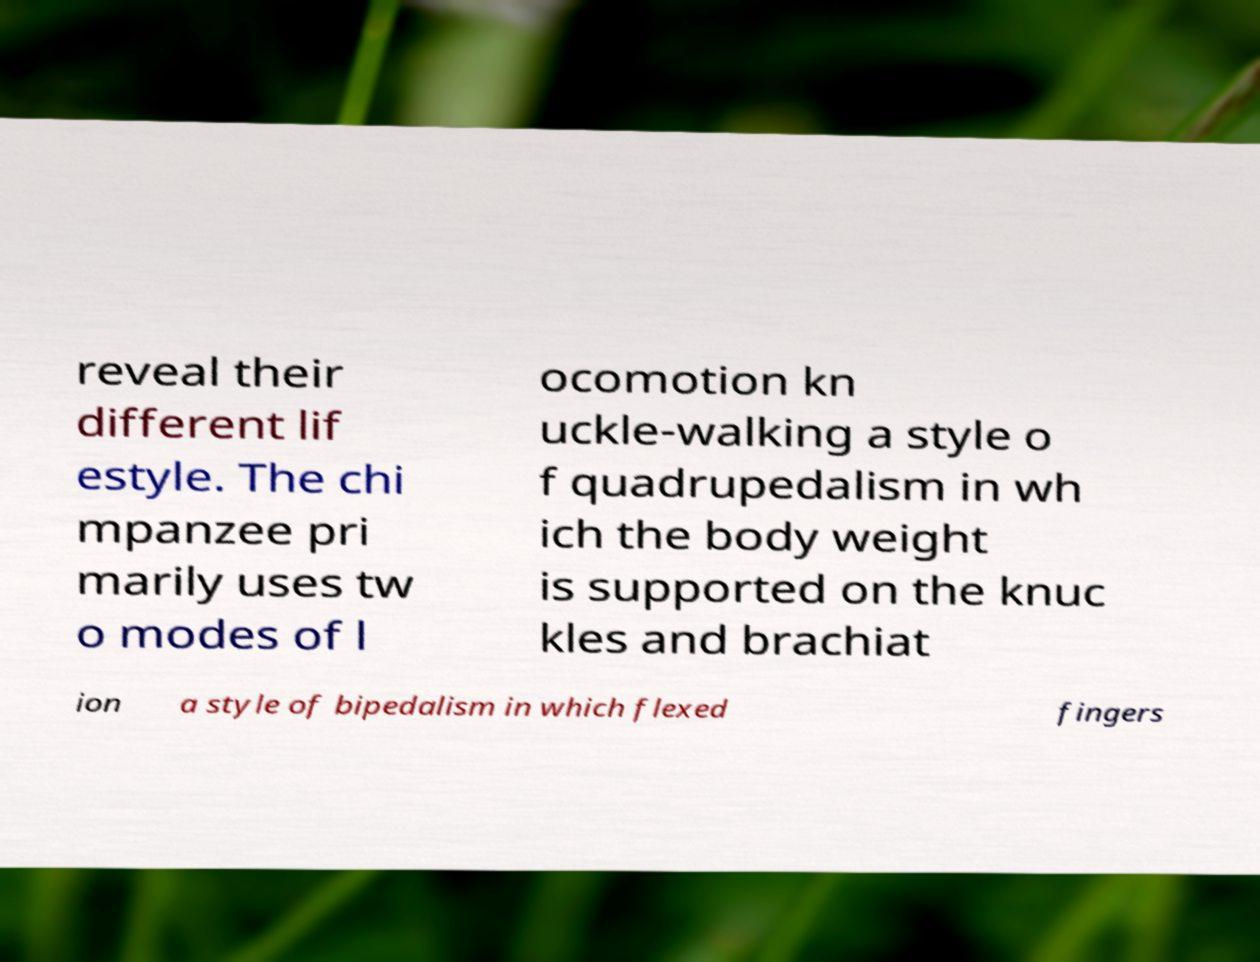Please identify and transcribe the text found in this image. reveal their different lif estyle. The chi mpanzee pri marily uses tw o modes of l ocomotion kn uckle-walking a style o f quadrupedalism in wh ich the body weight is supported on the knuc kles and brachiat ion a style of bipedalism in which flexed fingers 